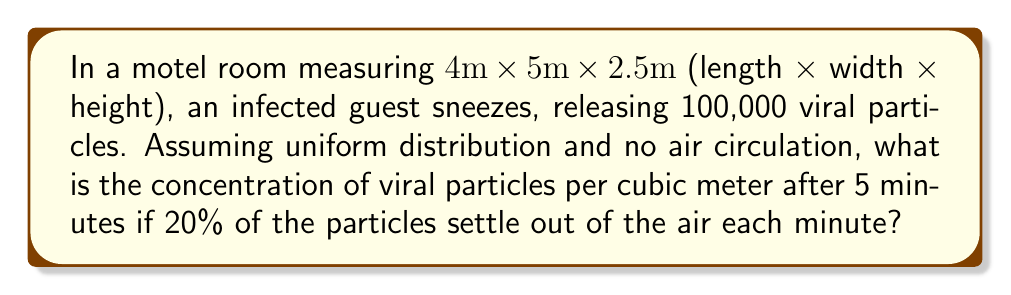Can you answer this question? Let's approach this step-by-step:

1. Calculate the volume of the room:
   $V = 4m \times 5m \times 2.5m = 50m^3$

2. Set up the equation for the number of particles remaining after t minutes:
   $N(t) = N_0 \times (0.8)^t$
   Where $N_0$ is the initial number of particles and 0.8 represents the 80% that remain airborne each minute.

3. Calculate the number of particles after 5 minutes:
   $N(5) = 100,000 \times (0.8)^5 = 100,000 \times 0.32768 = 32,768$ particles

4. Calculate the concentration per cubic meter:
   $C = \frac{N(5)}{V} = \frac{32,768}{50} = 655.36$ particles/m³

Therefore, the concentration of viral particles per cubic meter after 5 minutes is approximately 655 particles/m³.
Answer: 655 particles/m³ 